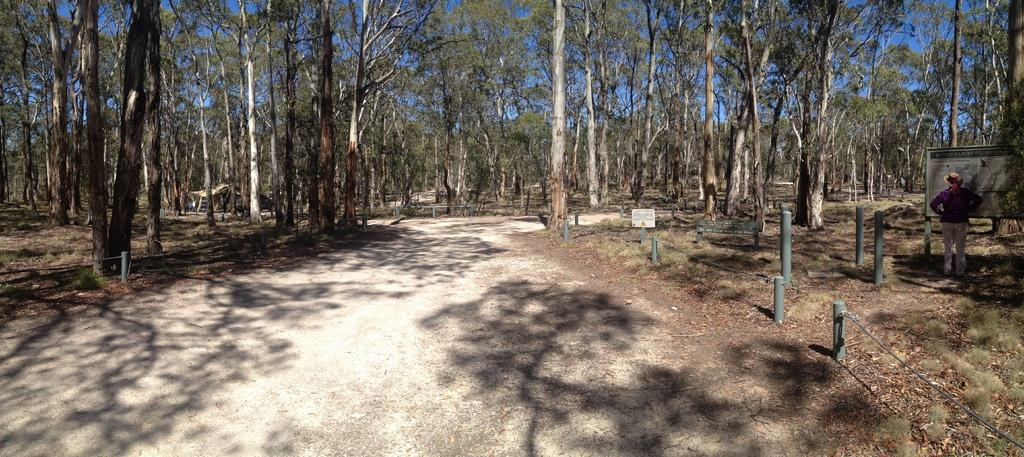What type of path is visible in the image? There is a walkway in the image. What can be seen in the background of the image? There are trees in the image. Where is the person located in the image? The person is standing on the right side of the image. What is the person standing near in the image? The person is near a board. What are the tall, thin structures in the image? There are poles in the image. What is the condition of the sky in the image? The sky is clear in the image. Can you hear the ants crawling on the board in the image? There are no ants present in the image, and therefore no such sound can be heard. What is the nationality of the person in the image? The nationality of the person cannot be determined from the image alone. 